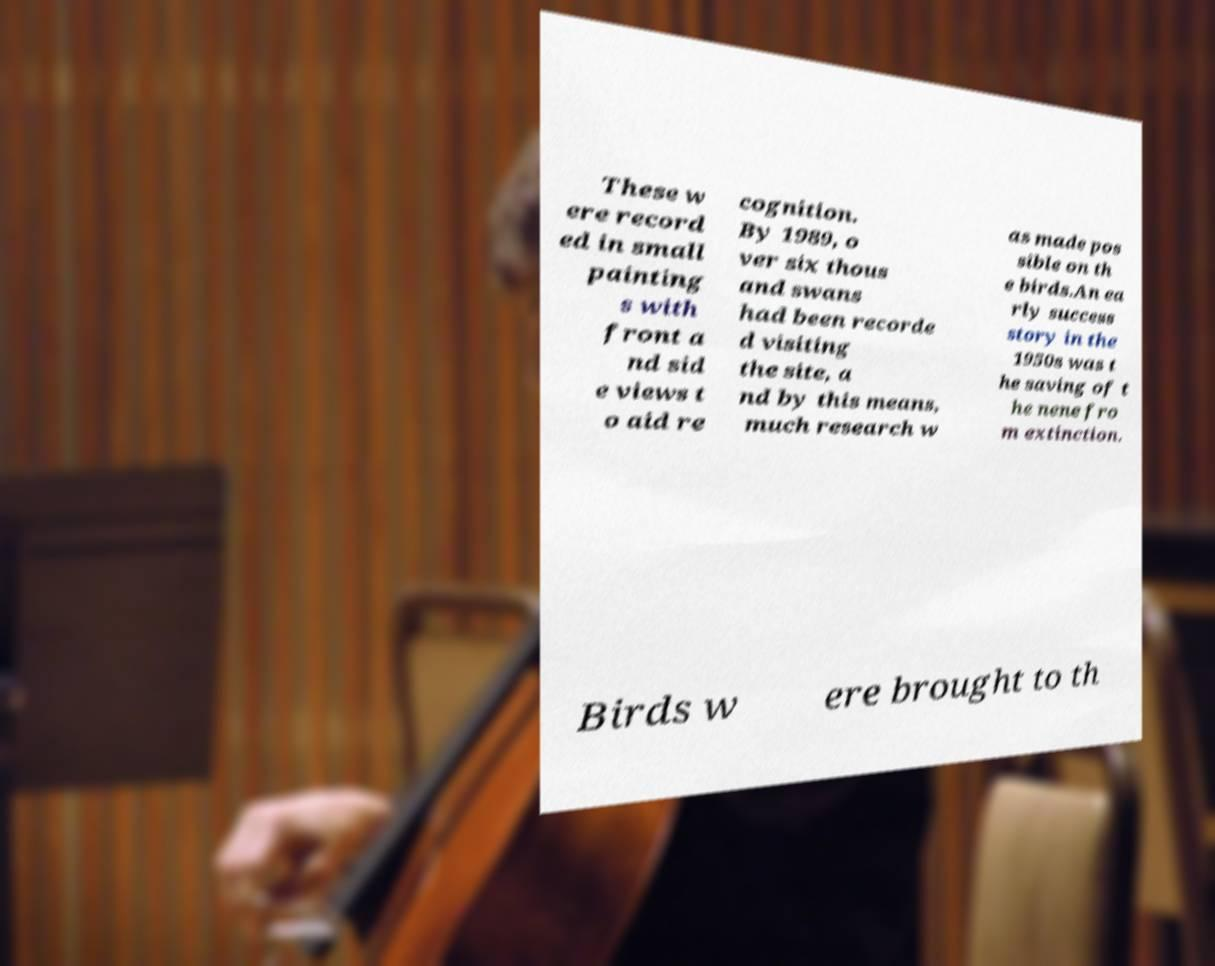What messages or text are displayed in this image? I need them in a readable, typed format. These w ere record ed in small painting s with front a nd sid e views t o aid re cognition. By 1989, o ver six thous and swans had been recorde d visiting the site, a nd by this means, much research w as made pos sible on th e birds.An ea rly success story in the 1950s was t he saving of t he nene fro m extinction. Birds w ere brought to th 